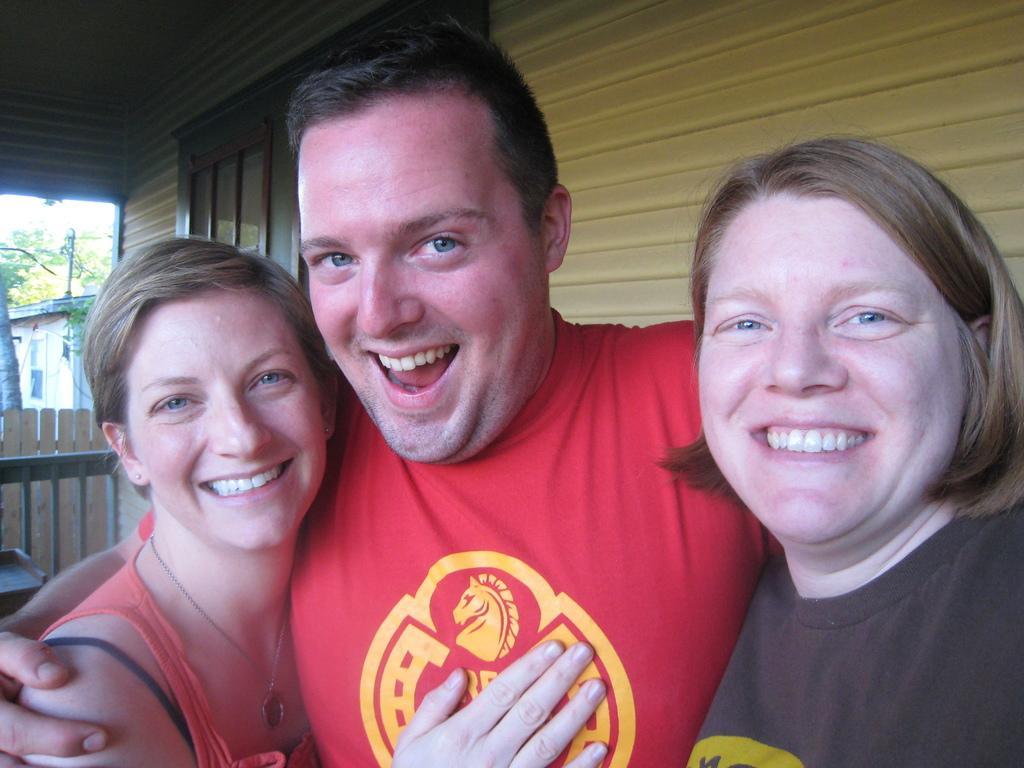How would you summarize this image in a sentence or two? In this image we can see three people standing in front of the building and in the background there are tree, fence, building and a table. 